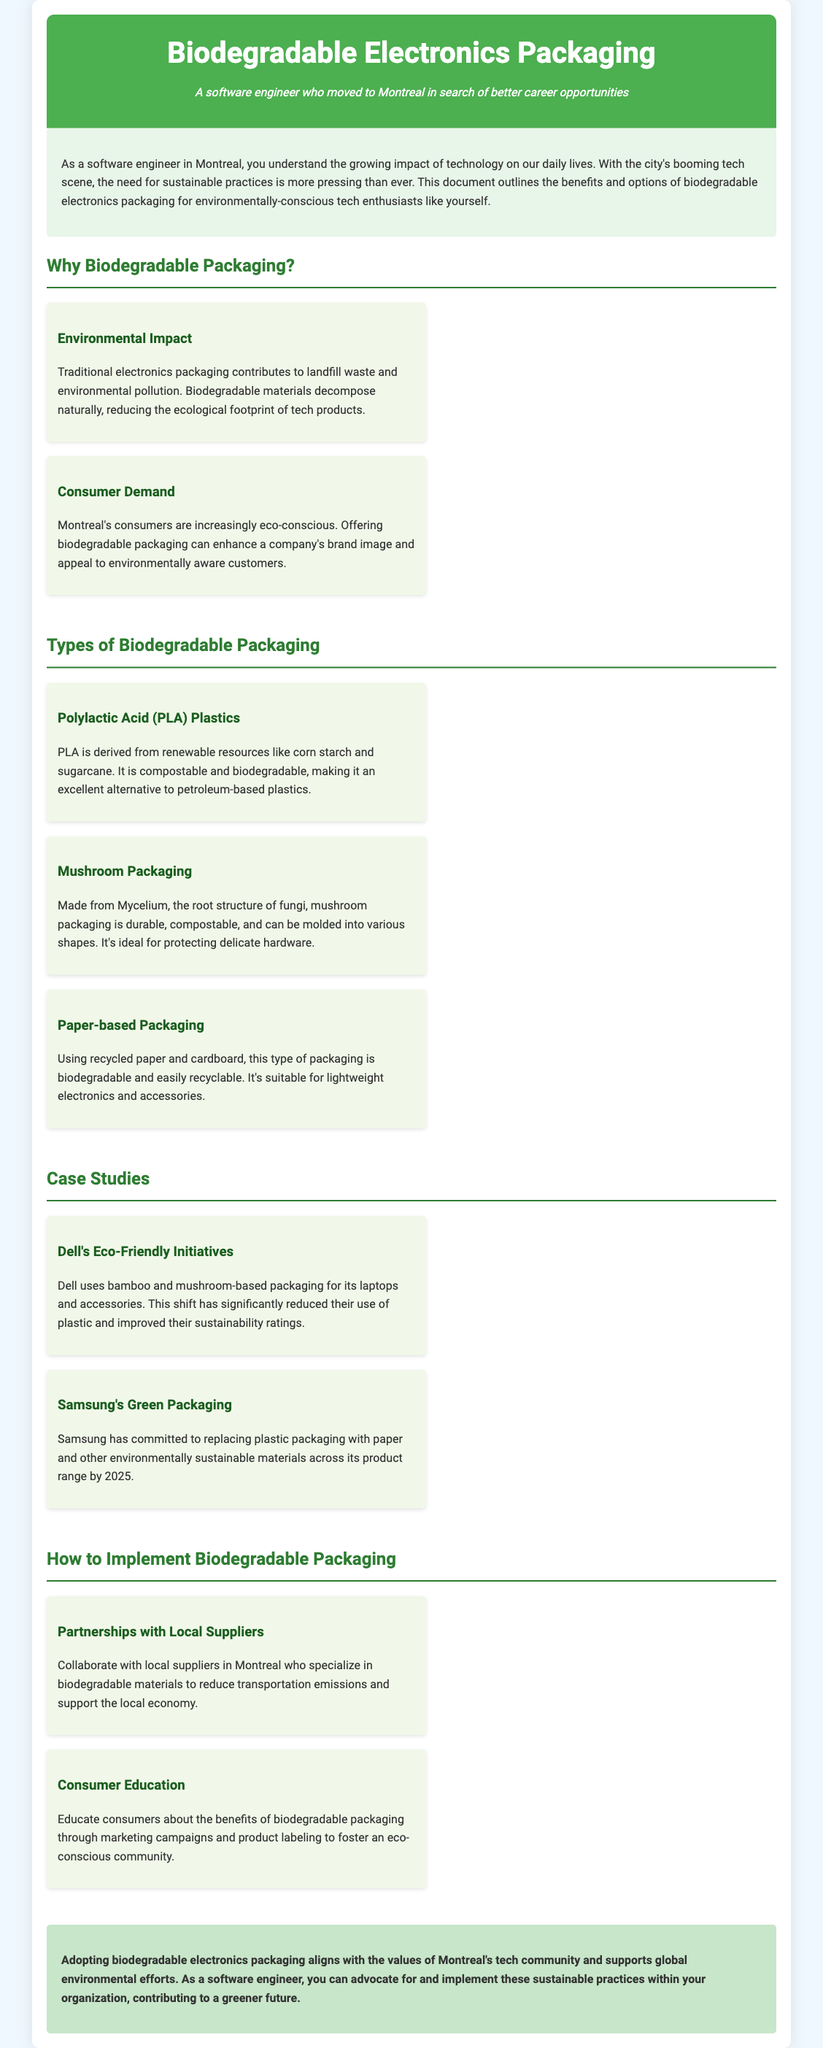What is the main benefit of biodegradable packaging? The main benefit is reducing the ecological footprint of tech products.
Answer: Reducing ecological footprint Which company uses bamboo and mushroom-based packaging? Dell is mentioned as using bamboo and mushroom-based packaging for its laptops and accessories.
Answer: Dell What type of biodegradable packaging is derived from renewable resources? Polylactic Acid (PLA) plastics are derived from renewable resources.
Answer: Polylactic Acid (PLA) plastics What is the primary material used in mushroom packaging? Mushroom packaging is made from Mycelium, the root structure of fungi.
Answer: Mycelium By what year has Samsung committed to replacing plastic packaging? Samsung has committed to replacing plastic packaging by 2025.
Answer: 2025 What strategy involves collaborating with local suppliers? Partnerships with local suppliers is the strategy mentioned for implementing biodegradable packaging.
Answer: Partnerships with local suppliers What is the ecological impact of traditional electronics packaging? Traditional electronics packaging contributes to landfill waste and environmental pollution.
Answer: Landfill waste and pollution How can companies enhance their brand image according to the document? Companies can enhance their brand image by offering biodegradable packaging.
Answer: Offering biodegradable packaging What type of packaging is suitable for lightweight electronics? Paper-based packaging is suitable for lightweight electronics.
Answer: Paper-based packaging 